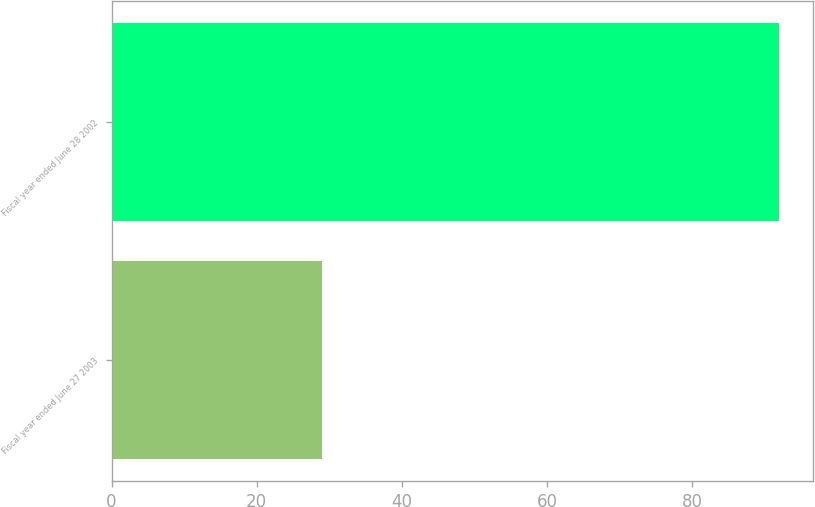Convert chart. <chart><loc_0><loc_0><loc_500><loc_500><bar_chart><fcel>Fiscal year ended June 27 2003<fcel>Fiscal year ended June 28 2002<nl><fcel>29<fcel>92<nl></chart> 